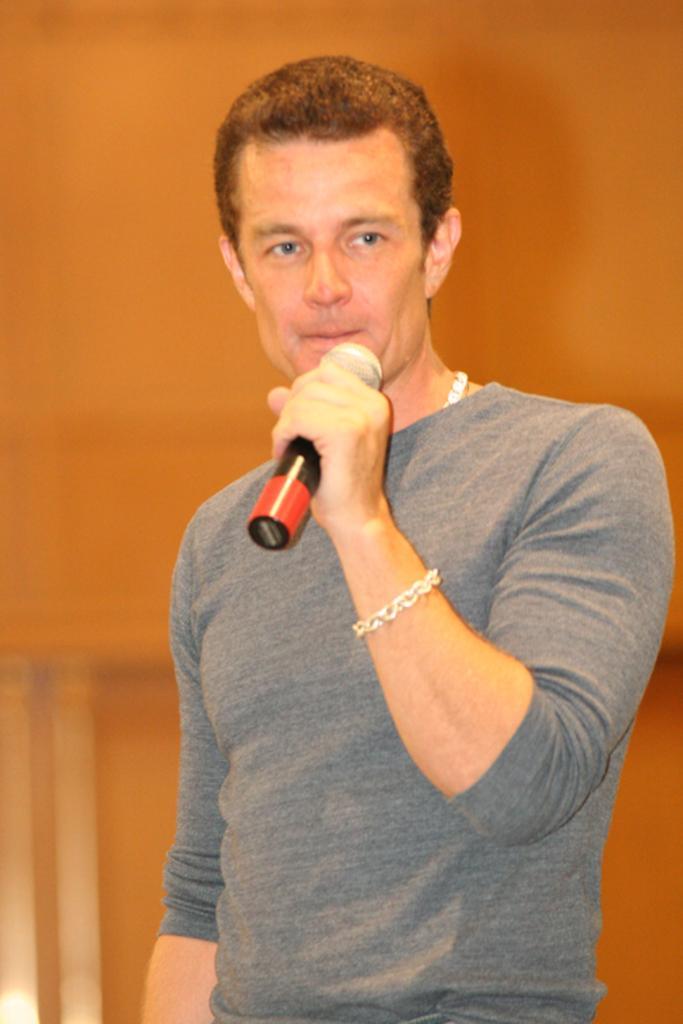Please provide a concise description of this image. In this image we can see a person standing and holding a mic and in the background we can see the wall. 